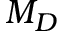<formula> <loc_0><loc_0><loc_500><loc_500>M _ { D }</formula> 